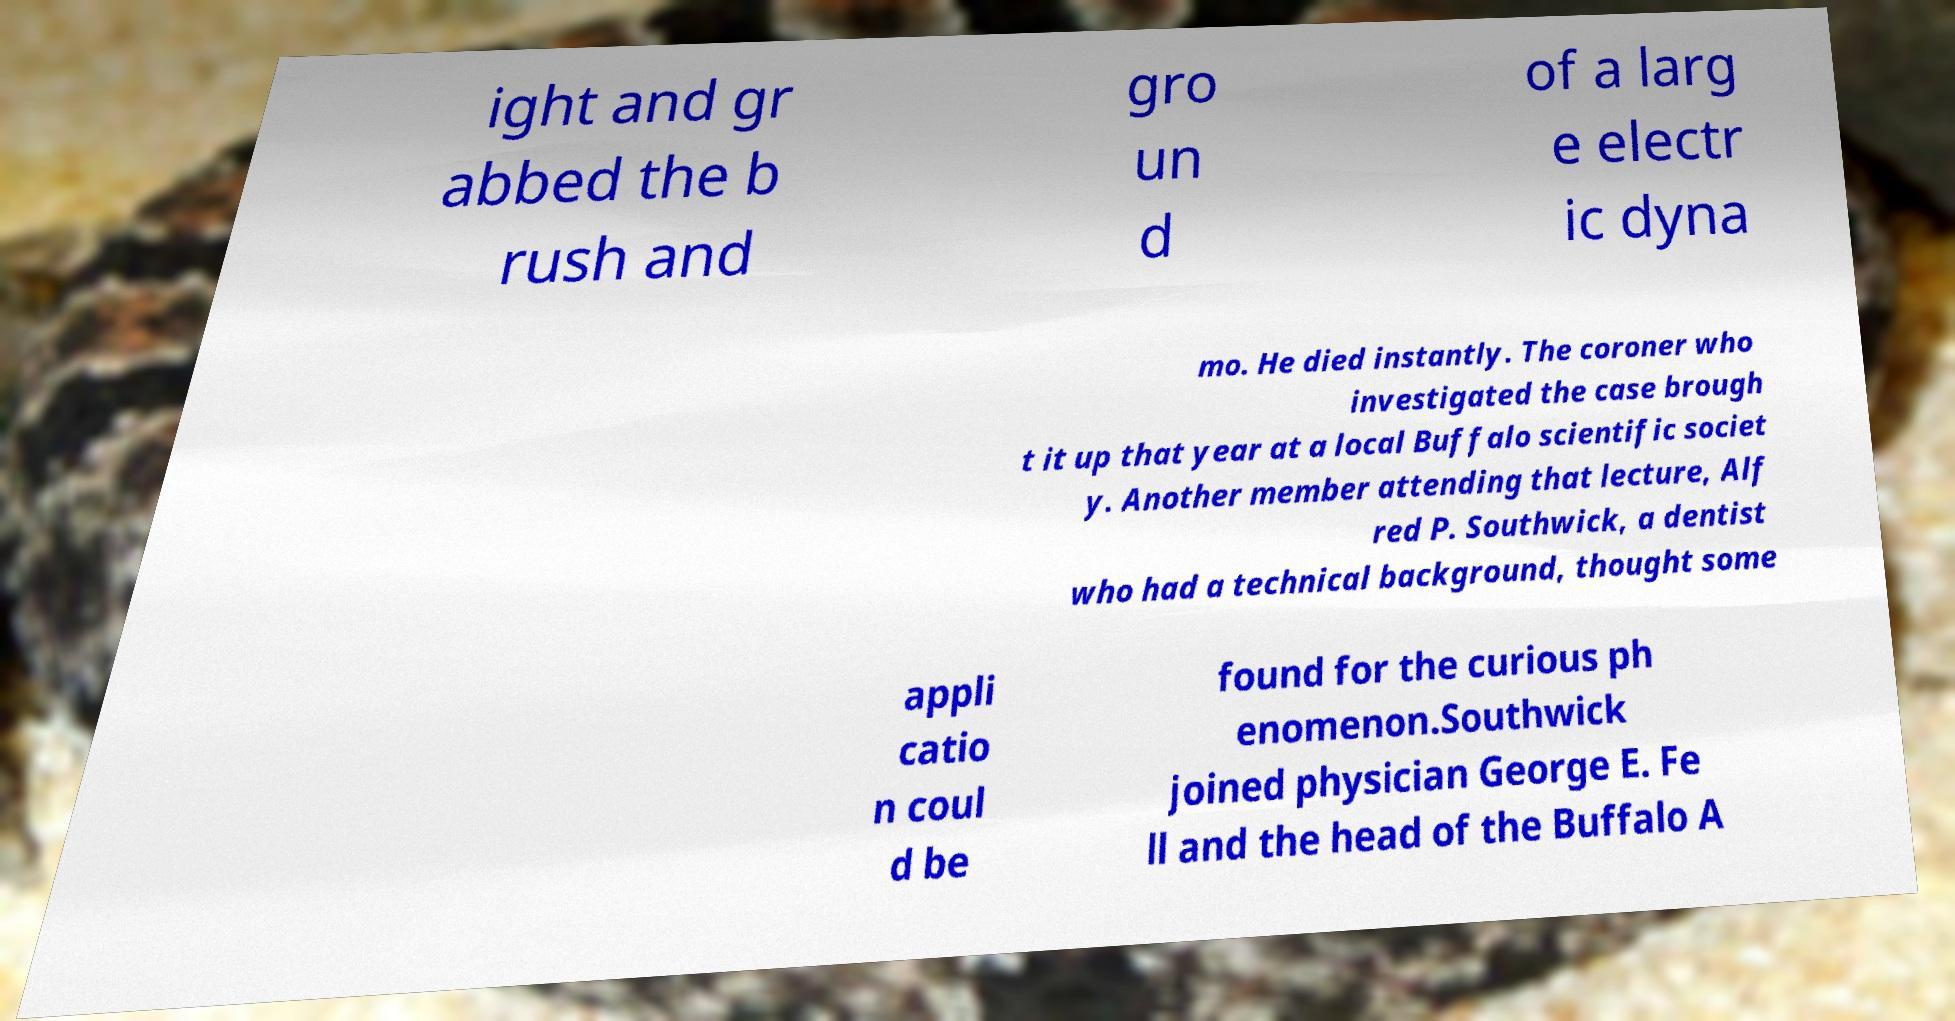Can you read and provide the text displayed in the image?This photo seems to have some interesting text. Can you extract and type it out for me? ight and gr abbed the b rush and gro un d of a larg e electr ic dyna mo. He died instantly. The coroner who investigated the case brough t it up that year at a local Buffalo scientific societ y. Another member attending that lecture, Alf red P. Southwick, a dentist who had a technical background, thought some appli catio n coul d be found for the curious ph enomenon.Southwick joined physician George E. Fe ll and the head of the Buffalo A 